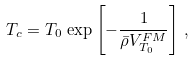<formula> <loc_0><loc_0><loc_500><loc_500>T _ { c } = T _ { 0 } \, \exp \left [ - \frac { 1 } { \bar { \rho } V ^ { F M } _ { T _ { 0 } } } \right ] \, ,</formula> 